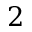<formula> <loc_0><loc_0><loc_500><loc_500>2</formula> 